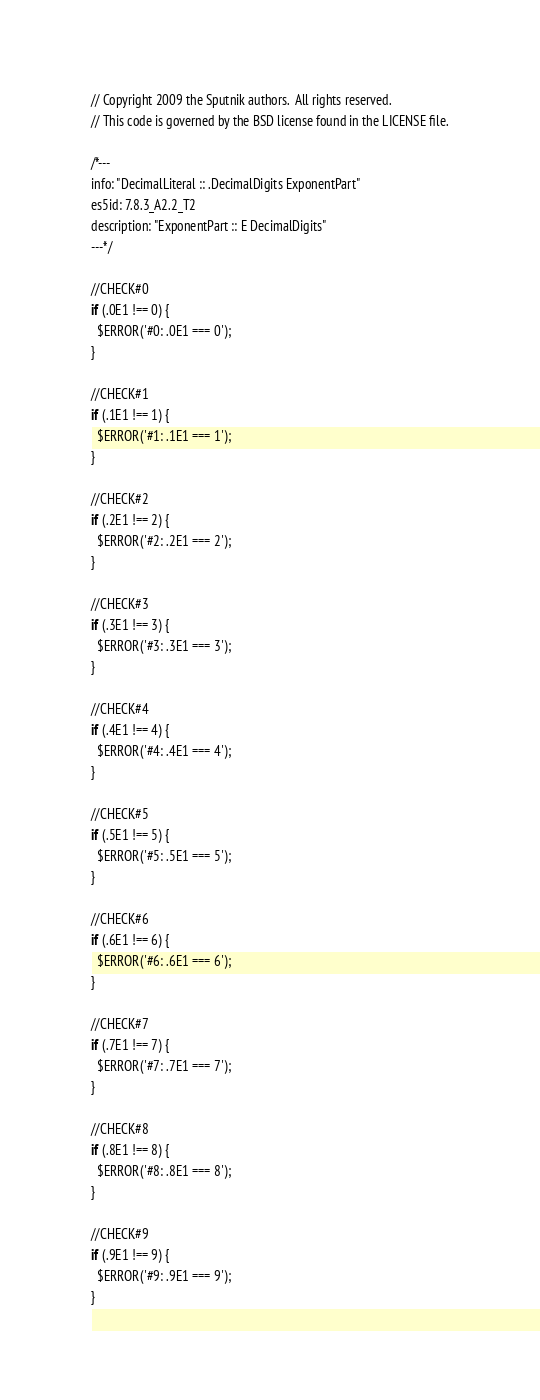Convert code to text. <code><loc_0><loc_0><loc_500><loc_500><_JavaScript_>// Copyright 2009 the Sputnik authors.  All rights reserved.
// This code is governed by the BSD license found in the LICENSE file.

/*---
info: "DecimalLiteral :: .DecimalDigits ExponentPart"
es5id: 7.8.3_A2.2_T2
description: "ExponentPart :: E DecimalDigits"
---*/

//CHECK#0
if (.0E1 !== 0) {
  $ERROR('#0: .0E1 === 0');
}

//CHECK#1
if (.1E1 !== 1) {
  $ERROR('#1: .1E1 === 1');
}

//CHECK#2
if (.2E1 !== 2) {
  $ERROR('#2: .2E1 === 2');
}

//CHECK#3
if (.3E1 !== 3) {
  $ERROR('#3: .3E1 === 3');
}

//CHECK#4
if (.4E1 !== 4) {
  $ERROR('#4: .4E1 === 4');
}

//CHECK#5
if (.5E1 !== 5) {
  $ERROR('#5: .5E1 === 5');
}

//CHECK#6
if (.6E1 !== 6) {
  $ERROR('#6: .6E1 === 6');
}

//CHECK#7
if (.7E1 !== 7) {
  $ERROR('#7: .7E1 === 7');
}

//CHECK#8
if (.8E1 !== 8) {
  $ERROR('#8: .8E1 === 8');
}

//CHECK#9
if (.9E1 !== 9) {
  $ERROR('#9: .9E1 === 9');
}
</code> 